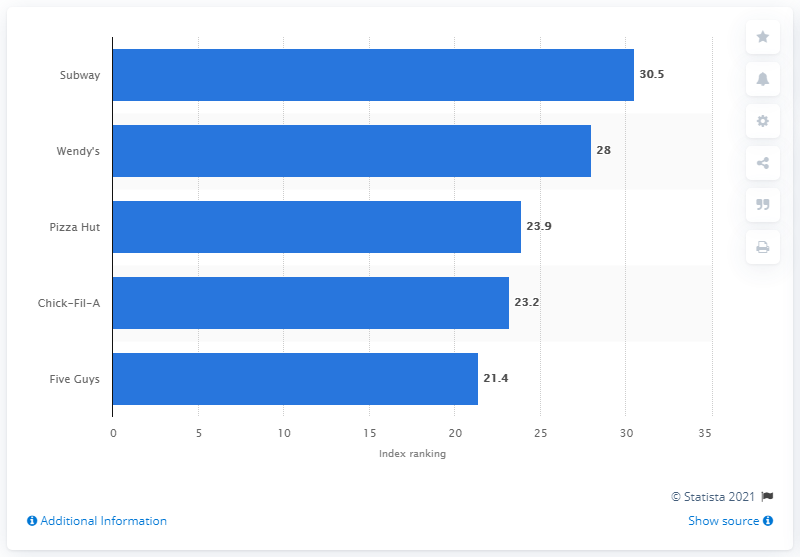Point out several critical features in this image. In the year 2018, Subway was ranked as the leading quick-service restaurant brand in the United States. 